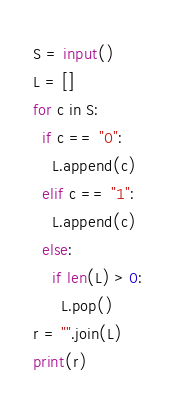<code> <loc_0><loc_0><loc_500><loc_500><_Python_>S = input()
L = []
for c in S:
  if c == "0":
    L.append(c)
  elif c == "1":
    L.append(c)
  else:
    if len(L) > 0:
      L.pop()
r = "".join(L)
print(r)
</code> 